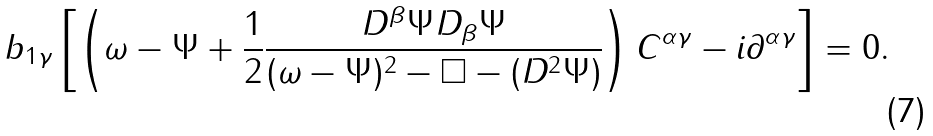Convert formula to latex. <formula><loc_0><loc_0><loc_500><loc_500>b _ { 1 \gamma } \left [ \left ( \omega - \Psi + \frac { 1 } { 2 } \frac { D ^ { \beta } \Psi D _ { \beta } \Psi } { ( \omega - \Psi ) ^ { 2 } - \Box - ( D ^ { 2 } \Psi ) } \right ) C ^ { \alpha \gamma } - i \partial ^ { \alpha \gamma } \right ] = 0 .</formula> 